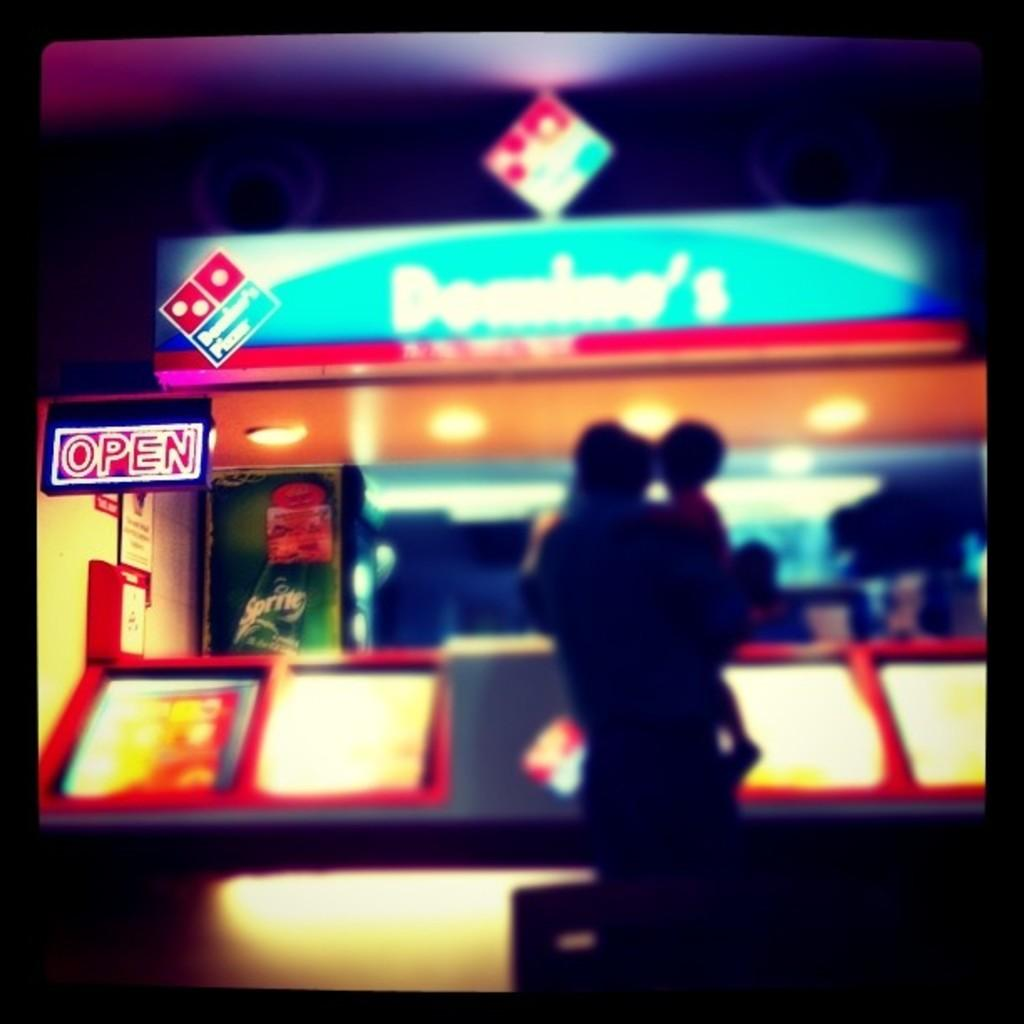Who is in the image? There is a person in the image. What is the person doing? The person is holding a baby. What is the person's posture in the image? The person is standing. What can be seen in the background of the image? There is a shop in the background of the image, which has a hoarding and lights. Are there any other objects visible in the background? Yes, there are other objects in the background of the image. What type of game is being played by the person in the image? There is no game being played in the image; the person is holding a baby. Is there any dirt visible on the person's clothes in the image? There is no information about the cleanliness of the person's clothes in the image. 